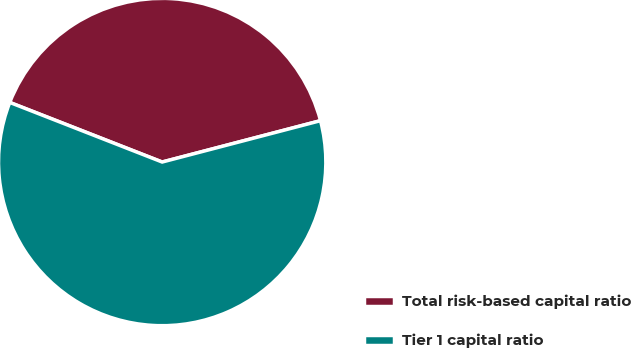Convert chart to OTSL. <chart><loc_0><loc_0><loc_500><loc_500><pie_chart><fcel>Total risk-based capital ratio<fcel>Tier 1 capital ratio<nl><fcel>40.0%<fcel>60.0%<nl></chart> 